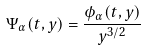Convert formula to latex. <formula><loc_0><loc_0><loc_500><loc_500>\Psi _ { \alpha } ( t , y ) = \frac { \phi _ { \alpha } ( t , y ) } { y ^ { 3 / 2 } }</formula> 